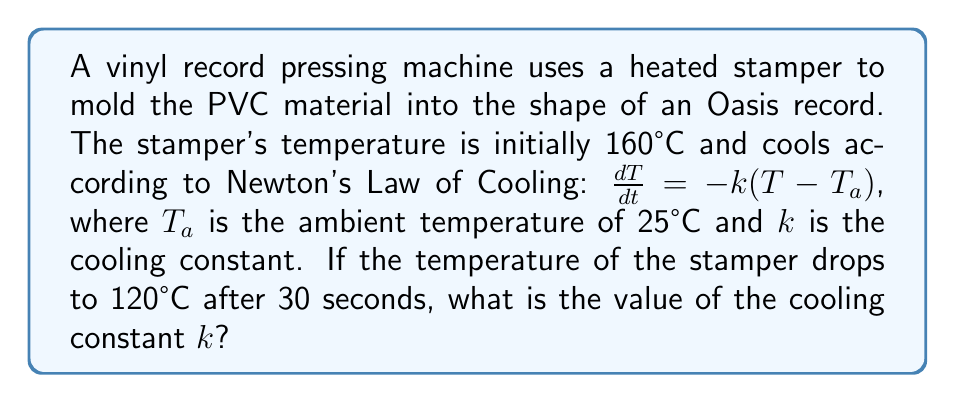Solve this math problem. Let's solve this step-by-step:

1) Newton's Law of Cooling is given by:
   $$\frac{dT}{dt} = -k(T - T_a)$$

2) The solution to this differential equation is:
   $$T(t) = T_a + (T_0 - T_a)e^{-kt}$$
   where $T_0$ is the initial temperature.

3) We know:
   - $T_0 = 160°C$
   - $T_a = 25°C$
   - After 30 seconds, $T(30) = 120°C$

4) Let's substitute these values into our equation:
   $$120 = 25 + (160 - 25)e^{-k(30)}$$

5) Simplify:
   $$95 = 135e^{-30k}$$

6) Divide both sides by 135:
   $$\frac{95}{135} = e^{-30k}$$

7) Take the natural log of both sides:
   $$\ln(\frac{95}{135}) = -30k$$

8) Solve for $k$:
   $$k = -\frac{1}{30}\ln(\frac{95}{135}) \approx 0.0123$$

Therefore, the cooling constant $k$ is approximately 0.0123 s^(-1).
Answer: $k \approx 0.0123$ s^(-1) 